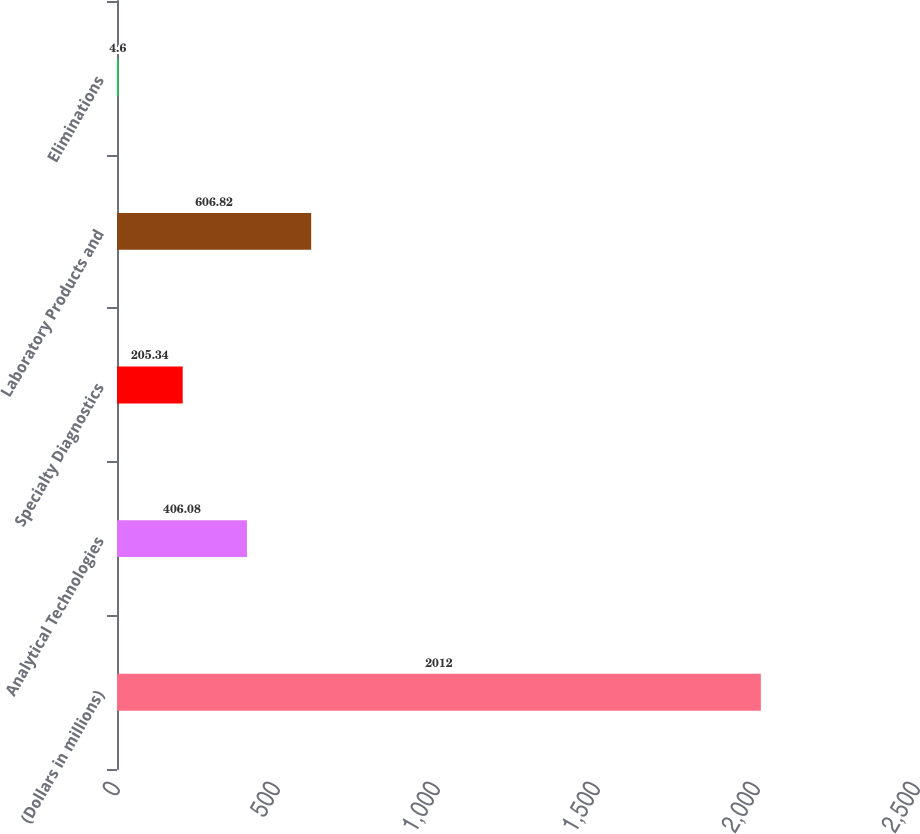Convert chart. <chart><loc_0><loc_0><loc_500><loc_500><bar_chart><fcel>(Dollars in millions)<fcel>Analytical Technologies<fcel>Specialty Diagnostics<fcel>Laboratory Products and<fcel>Eliminations<nl><fcel>2012<fcel>406.08<fcel>205.34<fcel>606.82<fcel>4.6<nl></chart> 